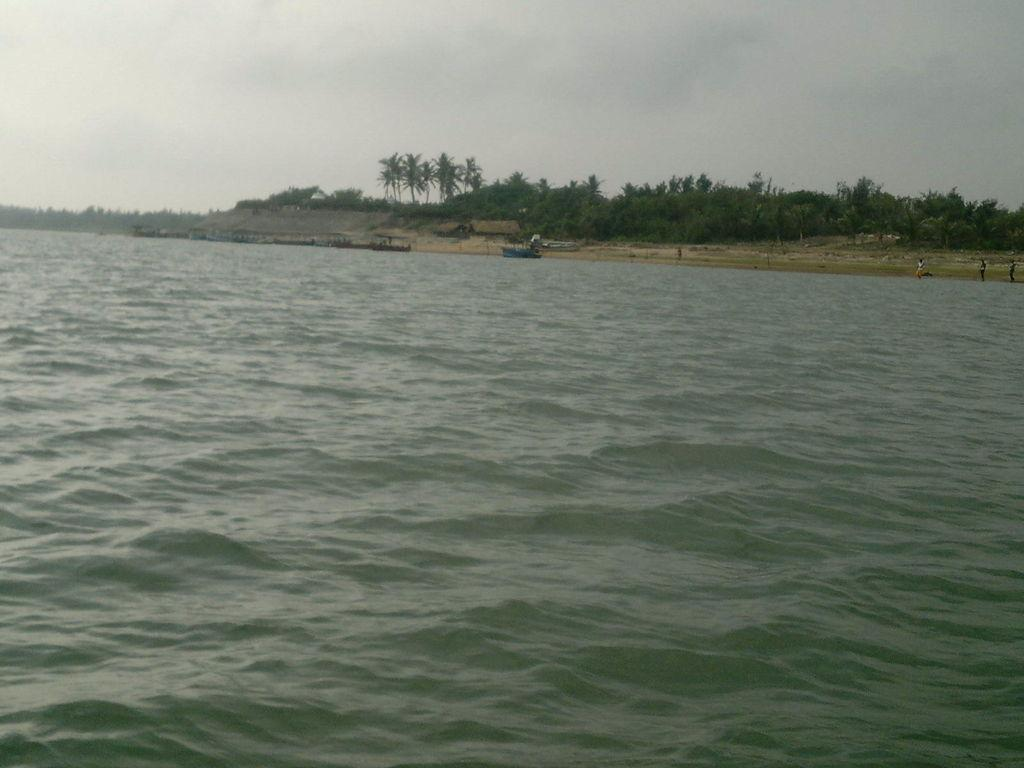What is in the foreground of the image? There is water in the foreground of the image. What can be seen in the background of the image? There are boats, huts, trees, people, and clouds visible in the background of the image. What type of brass instrument is being played by the people in the background of the image? There is no brass instrument or any musical instrument being played in the image. Can you see a field in the background of the image? There is no field visible in the background of the image; it features water, boats, huts, trees, people, and clouds. 